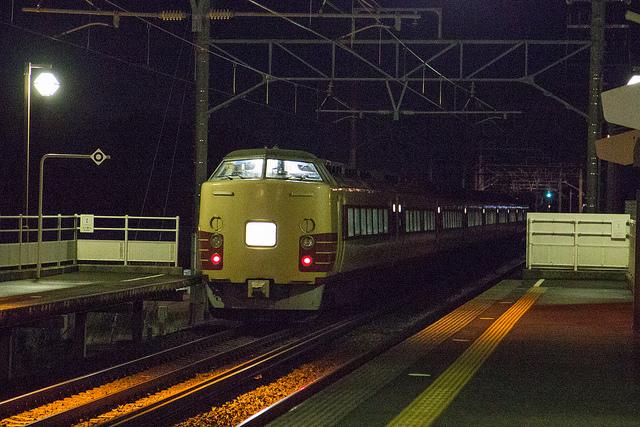Does it look like it is the middle of night?
Give a very brief answer. Yes. Are any of the lights turned on?
Answer briefly. Yes. Is this an electric or diesel train?
Concise answer only. Electric. 